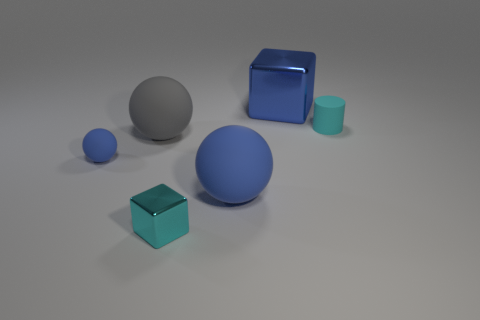Add 2 large green shiny cylinders. How many objects exist? 8 Subtract all cylinders. How many objects are left? 5 Add 4 small brown rubber spheres. How many small brown rubber spheres exist? 4 Subtract 0 gray cylinders. How many objects are left? 6 Subtract all tiny blue shiny balls. Subtract all matte objects. How many objects are left? 2 Add 3 big blue metal blocks. How many big blue metal blocks are left? 4 